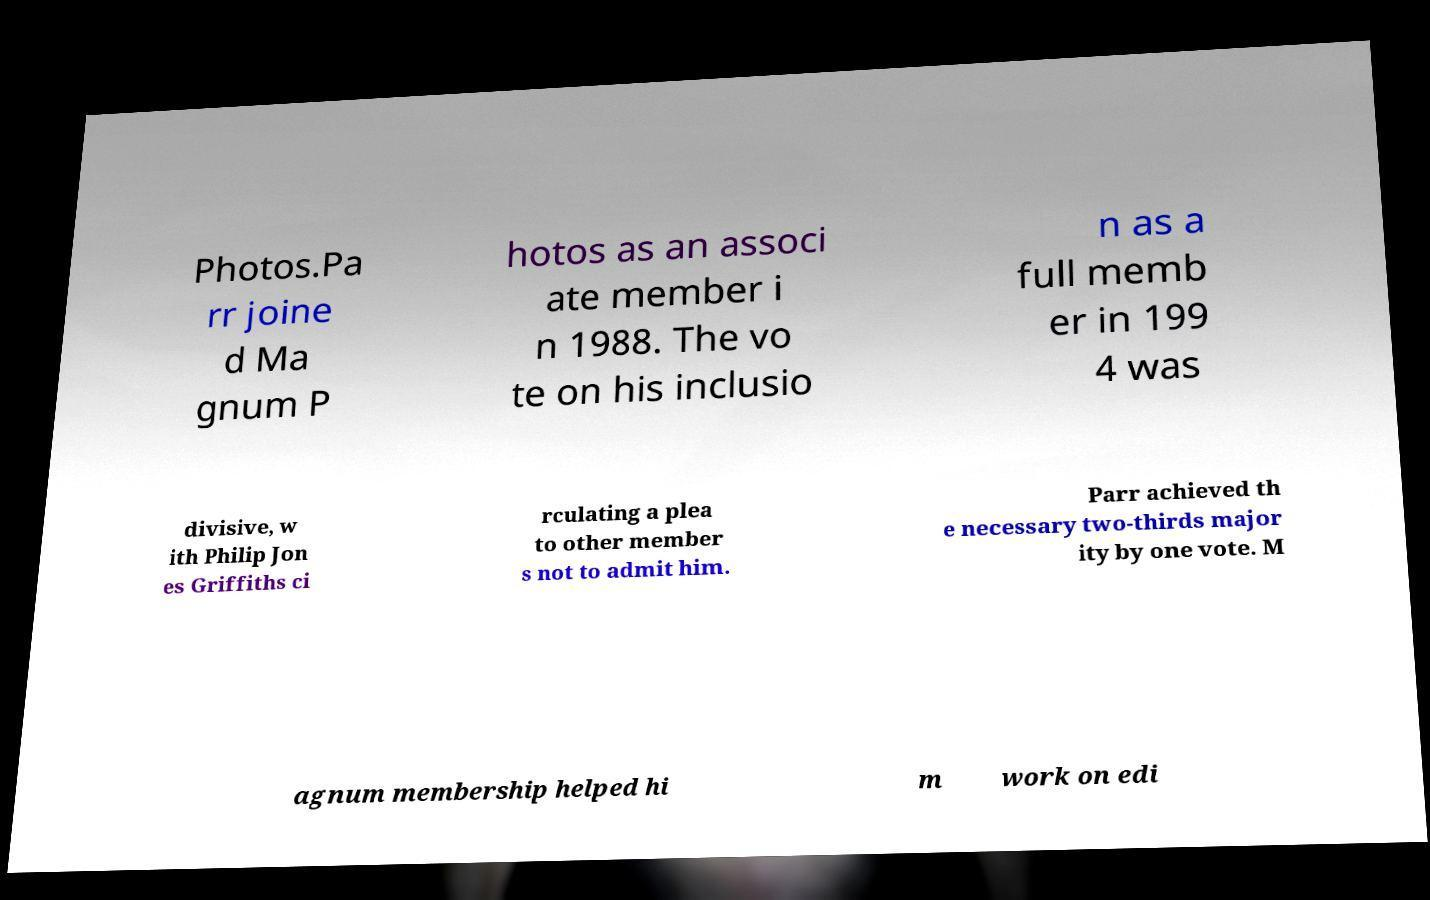Can you read and provide the text displayed in the image?This photo seems to have some interesting text. Can you extract and type it out for me? Photos.Pa rr joine d Ma gnum P hotos as an associ ate member i n 1988. The vo te on his inclusio n as a full memb er in 199 4 was divisive, w ith Philip Jon es Griffiths ci rculating a plea to other member s not to admit him. Parr achieved th e necessary two-thirds major ity by one vote. M agnum membership helped hi m work on edi 